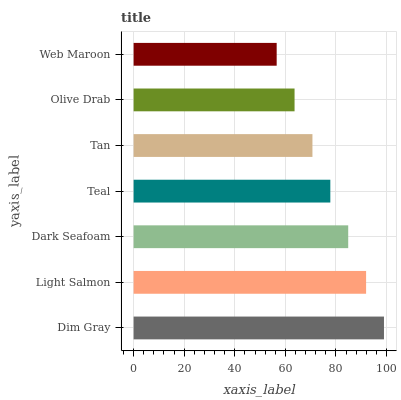Is Web Maroon the minimum?
Answer yes or no. Yes. Is Dim Gray the maximum?
Answer yes or no. Yes. Is Light Salmon the minimum?
Answer yes or no. No. Is Light Salmon the maximum?
Answer yes or no. No. Is Dim Gray greater than Light Salmon?
Answer yes or no. Yes. Is Light Salmon less than Dim Gray?
Answer yes or no. Yes. Is Light Salmon greater than Dim Gray?
Answer yes or no. No. Is Dim Gray less than Light Salmon?
Answer yes or no. No. Is Teal the high median?
Answer yes or no. Yes. Is Teal the low median?
Answer yes or no. Yes. Is Olive Drab the high median?
Answer yes or no. No. Is Tan the low median?
Answer yes or no. No. 